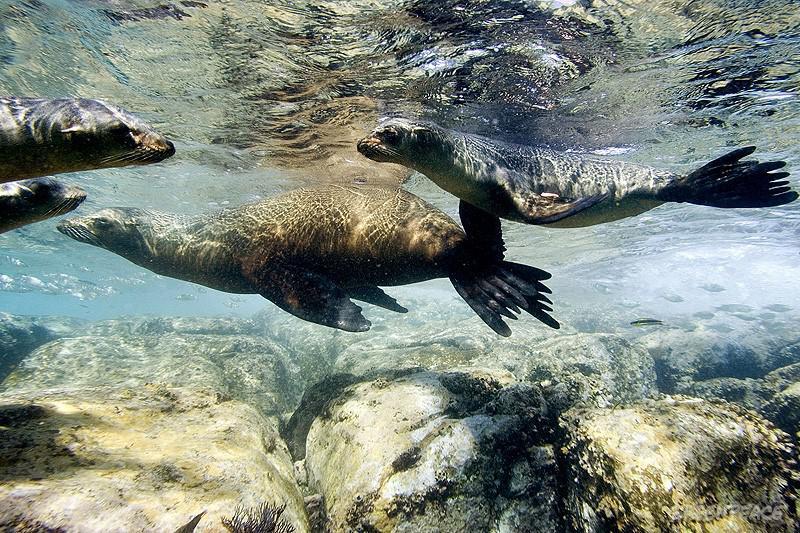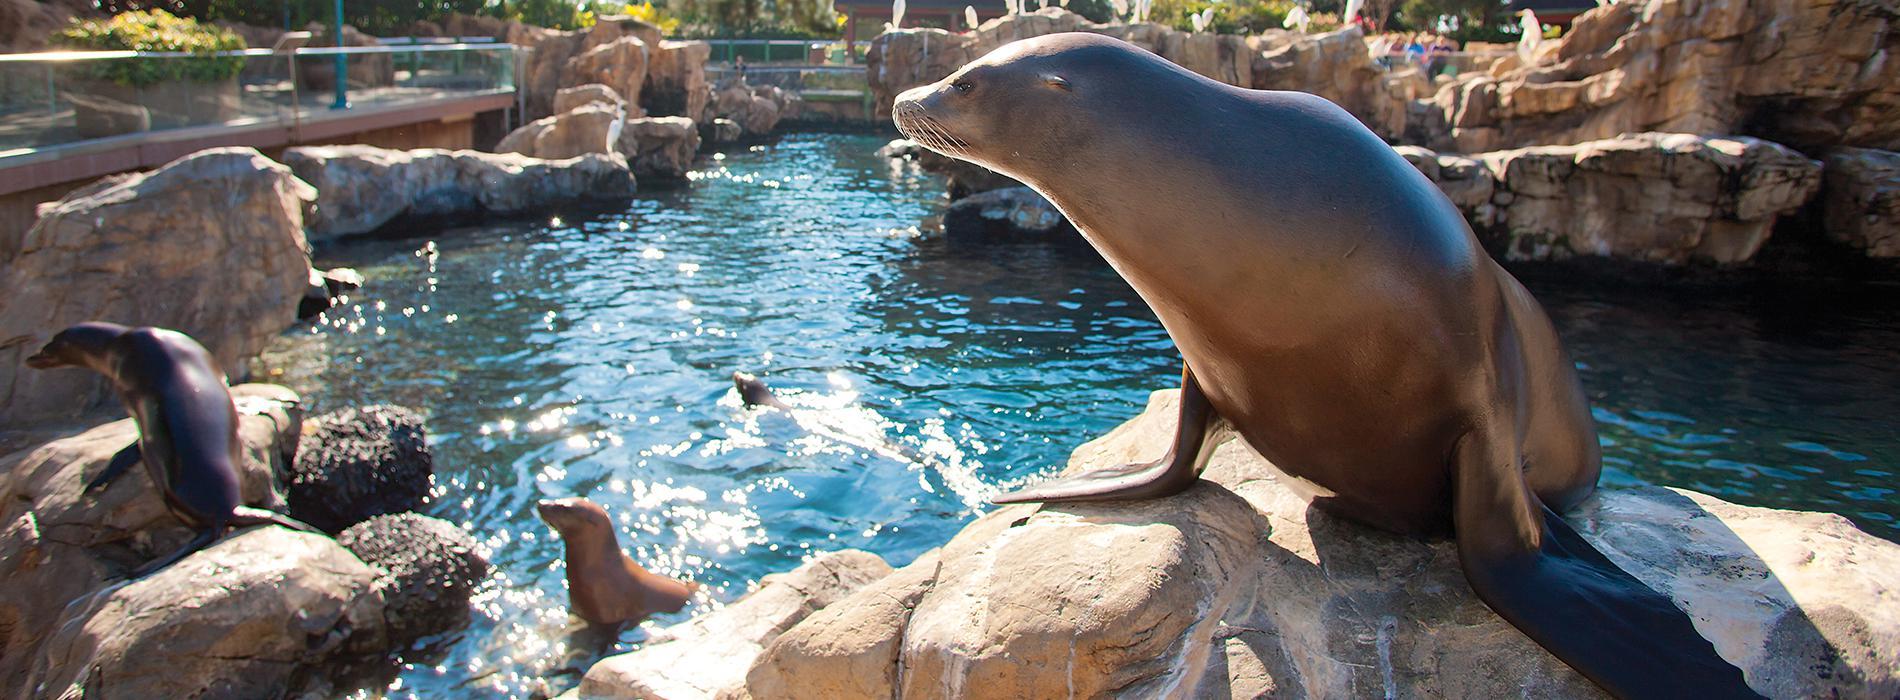The first image is the image on the left, the second image is the image on the right. For the images displayed, is the sentence "One image shows seals above the water, sharing piles of rocks with birds." factually correct? Answer yes or no. No. The first image is the image on the left, the second image is the image on the right. Analyze the images presented: Is the assertion "Some of the sea lions are swimming in open water." valid? Answer yes or no. Yes. 